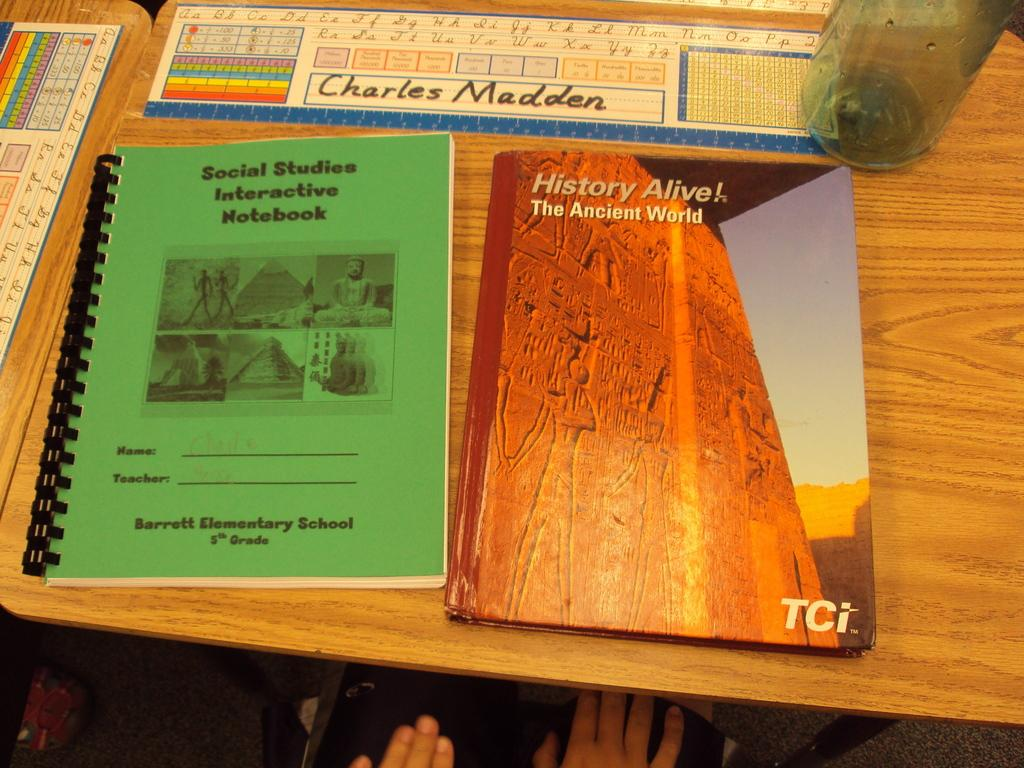<image>
Summarize the visual content of the image. The 5th graders at Barrett Elementary School use a green interactive notebook for Social Studies. 